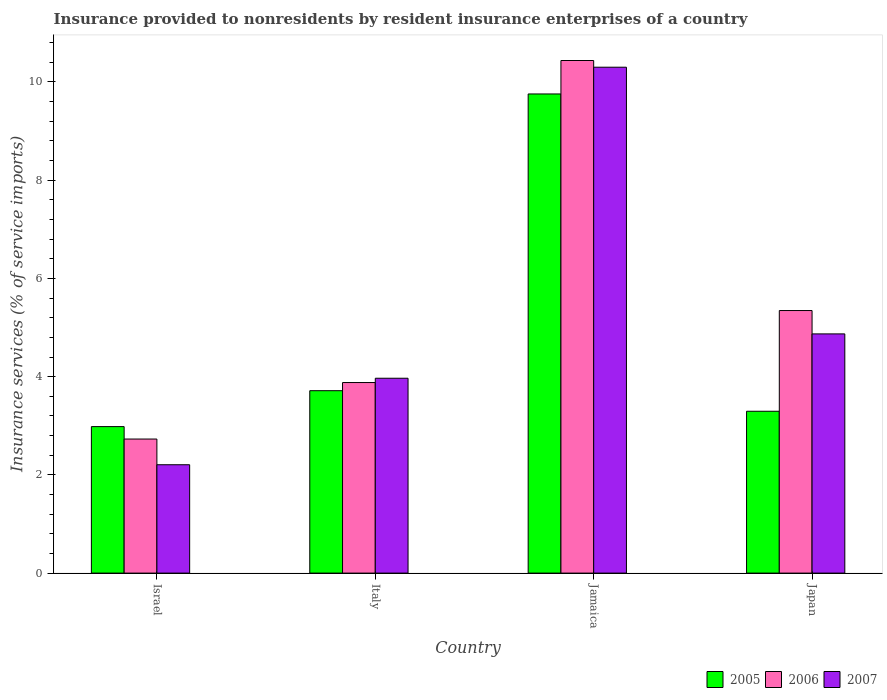How many different coloured bars are there?
Your answer should be very brief. 3. Are the number of bars per tick equal to the number of legend labels?
Your answer should be compact. Yes. Are the number of bars on each tick of the X-axis equal?
Provide a succinct answer. Yes. How many bars are there on the 4th tick from the left?
Offer a terse response. 3. How many bars are there on the 4th tick from the right?
Your answer should be compact. 3. What is the label of the 2nd group of bars from the left?
Your answer should be compact. Italy. In how many cases, is the number of bars for a given country not equal to the number of legend labels?
Your answer should be very brief. 0. What is the insurance provided to nonresidents in 2006 in Italy?
Your answer should be compact. 3.88. Across all countries, what is the maximum insurance provided to nonresidents in 2007?
Ensure brevity in your answer.  10.3. Across all countries, what is the minimum insurance provided to nonresidents in 2005?
Ensure brevity in your answer.  2.98. In which country was the insurance provided to nonresidents in 2006 maximum?
Give a very brief answer. Jamaica. What is the total insurance provided to nonresidents in 2006 in the graph?
Offer a terse response. 22.39. What is the difference between the insurance provided to nonresidents in 2005 in Israel and that in Japan?
Offer a very short reply. -0.31. What is the difference between the insurance provided to nonresidents in 2007 in Italy and the insurance provided to nonresidents in 2006 in Israel?
Provide a short and direct response. 1.24. What is the average insurance provided to nonresidents in 2007 per country?
Provide a succinct answer. 5.34. What is the difference between the insurance provided to nonresidents of/in 2006 and insurance provided to nonresidents of/in 2007 in Japan?
Offer a very short reply. 0.48. What is the ratio of the insurance provided to nonresidents in 2006 in Jamaica to that in Japan?
Your response must be concise. 1.95. What is the difference between the highest and the second highest insurance provided to nonresidents in 2006?
Offer a very short reply. 6.56. What is the difference between the highest and the lowest insurance provided to nonresidents in 2007?
Offer a very short reply. 8.09. Is the sum of the insurance provided to nonresidents in 2007 in Jamaica and Japan greater than the maximum insurance provided to nonresidents in 2005 across all countries?
Your answer should be very brief. Yes. What does the 2nd bar from the left in Israel represents?
Keep it short and to the point. 2006. What does the 3rd bar from the right in Jamaica represents?
Offer a very short reply. 2005. Is it the case that in every country, the sum of the insurance provided to nonresidents in 2007 and insurance provided to nonresidents in 2005 is greater than the insurance provided to nonresidents in 2006?
Offer a very short reply. Yes. Are all the bars in the graph horizontal?
Give a very brief answer. No. How many legend labels are there?
Give a very brief answer. 3. What is the title of the graph?
Your answer should be compact. Insurance provided to nonresidents by resident insurance enterprises of a country. Does "2002" appear as one of the legend labels in the graph?
Keep it short and to the point. No. What is the label or title of the X-axis?
Your answer should be compact. Country. What is the label or title of the Y-axis?
Offer a terse response. Insurance services (% of service imports). What is the Insurance services (% of service imports) of 2005 in Israel?
Offer a terse response. 2.98. What is the Insurance services (% of service imports) in 2006 in Israel?
Give a very brief answer. 2.73. What is the Insurance services (% of service imports) in 2007 in Israel?
Offer a very short reply. 2.21. What is the Insurance services (% of service imports) in 2005 in Italy?
Ensure brevity in your answer.  3.71. What is the Insurance services (% of service imports) in 2006 in Italy?
Give a very brief answer. 3.88. What is the Insurance services (% of service imports) of 2007 in Italy?
Keep it short and to the point. 3.97. What is the Insurance services (% of service imports) in 2005 in Jamaica?
Ensure brevity in your answer.  9.76. What is the Insurance services (% of service imports) in 2006 in Jamaica?
Provide a succinct answer. 10.44. What is the Insurance services (% of service imports) of 2007 in Jamaica?
Give a very brief answer. 10.3. What is the Insurance services (% of service imports) of 2005 in Japan?
Provide a succinct answer. 3.3. What is the Insurance services (% of service imports) of 2006 in Japan?
Provide a short and direct response. 5.35. What is the Insurance services (% of service imports) of 2007 in Japan?
Ensure brevity in your answer.  4.87. Across all countries, what is the maximum Insurance services (% of service imports) of 2005?
Your answer should be compact. 9.76. Across all countries, what is the maximum Insurance services (% of service imports) of 2006?
Provide a short and direct response. 10.44. Across all countries, what is the maximum Insurance services (% of service imports) of 2007?
Your answer should be compact. 10.3. Across all countries, what is the minimum Insurance services (% of service imports) in 2005?
Provide a short and direct response. 2.98. Across all countries, what is the minimum Insurance services (% of service imports) in 2006?
Ensure brevity in your answer.  2.73. Across all countries, what is the minimum Insurance services (% of service imports) in 2007?
Give a very brief answer. 2.21. What is the total Insurance services (% of service imports) of 2005 in the graph?
Keep it short and to the point. 19.75. What is the total Insurance services (% of service imports) of 2006 in the graph?
Offer a terse response. 22.39. What is the total Insurance services (% of service imports) of 2007 in the graph?
Provide a short and direct response. 21.34. What is the difference between the Insurance services (% of service imports) of 2005 in Israel and that in Italy?
Keep it short and to the point. -0.73. What is the difference between the Insurance services (% of service imports) of 2006 in Israel and that in Italy?
Give a very brief answer. -1.15. What is the difference between the Insurance services (% of service imports) of 2007 in Israel and that in Italy?
Your response must be concise. -1.76. What is the difference between the Insurance services (% of service imports) of 2005 in Israel and that in Jamaica?
Offer a very short reply. -6.77. What is the difference between the Insurance services (% of service imports) of 2006 in Israel and that in Jamaica?
Keep it short and to the point. -7.71. What is the difference between the Insurance services (% of service imports) in 2007 in Israel and that in Jamaica?
Offer a very short reply. -8.09. What is the difference between the Insurance services (% of service imports) of 2005 in Israel and that in Japan?
Give a very brief answer. -0.31. What is the difference between the Insurance services (% of service imports) of 2006 in Israel and that in Japan?
Make the answer very short. -2.62. What is the difference between the Insurance services (% of service imports) in 2007 in Israel and that in Japan?
Give a very brief answer. -2.66. What is the difference between the Insurance services (% of service imports) of 2005 in Italy and that in Jamaica?
Keep it short and to the point. -6.04. What is the difference between the Insurance services (% of service imports) in 2006 in Italy and that in Jamaica?
Keep it short and to the point. -6.56. What is the difference between the Insurance services (% of service imports) in 2007 in Italy and that in Jamaica?
Give a very brief answer. -6.33. What is the difference between the Insurance services (% of service imports) of 2005 in Italy and that in Japan?
Make the answer very short. 0.42. What is the difference between the Insurance services (% of service imports) in 2006 in Italy and that in Japan?
Your answer should be very brief. -1.47. What is the difference between the Insurance services (% of service imports) of 2007 in Italy and that in Japan?
Give a very brief answer. -0.9. What is the difference between the Insurance services (% of service imports) of 2005 in Jamaica and that in Japan?
Your response must be concise. 6.46. What is the difference between the Insurance services (% of service imports) in 2006 in Jamaica and that in Japan?
Your answer should be very brief. 5.09. What is the difference between the Insurance services (% of service imports) of 2007 in Jamaica and that in Japan?
Your answer should be compact. 5.43. What is the difference between the Insurance services (% of service imports) in 2005 in Israel and the Insurance services (% of service imports) in 2006 in Italy?
Make the answer very short. -0.9. What is the difference between the Insurance services (% of service imports) in 2005 in Israel and the Insurance services (% of service imports) in 2007 in Italy?
Offer a terse response. -0.98. What is the difference between the Insurance services (% of service imports) in 2006 in Israel and the Insurance services (% of service imports) in 2007 in Italy?
Make the answer very short. -1.24. What is the difference between the Insurance services (% of service imports) of 2005 in Israel and the Insurance services (% of service imports) of 2006 in Jamaica?
Make the answer very short. -7.45. What is the difference between the Insurance services (% of service imports) in 2005 in Israel and the Insurance services (% of service imports) in 2007 in Jamaica?
Ensure brevity in your answer.  -7.32. What is the difference between the Insurance services (% of service imports) of 2006 in Israel and the Insurance services (% of service imports) of 2007 in Jamaica?
Your answer should be compact. -7.57. What is the difference between the Insurance services (% of service imports) of 2005 in Israel and the Insurance services (% of service imports) of 2006 in Japan?
Provide a short and direct response. -2.36. What is the difference between the Insurance services (% of service imports) of 2005 in Israel and the Insurance services (% of service imports) of 2007 in Japan?
Provide a short and direct response. -1.89. What is the difference between the Insurance services (% of service imports) in 2006 in Israel and the Insurance services (% of service imports) in 2007 in Japan?
Offer a very short reply. -2.14. What is the difference between the Insurance services (% of service imports) in 2005 in Italy and the Insurance services (% of service imports) in 2006 in Jamaica?
Provide a succinct answer. -6.72. What is the difference between the Insurance services (% of service imports) in 2005 in Italy and the Insurance services (% of service imports) in 2007 in Jamaica?
Offer a very short reply. -6.59. What is the difference between the Insurance services (% of service imports) of 2006 in Italy and the Insurance services (% of service imports) of 2007 in Jamaica?
Provide a succinct answer. -6.42. What is the difference between the Insurance services (% of service imports) in 2005 in Italy and the Insurance services (% of service imports) in 2006 in Japan?
Your answer should be compact. -1.63. What is the difference between the Insurance services (% of service imports) in 2005 in Italy and the Insurance services (% of service imports) in 2007 in Japan?
Offer a very short reply. -1.16. What is the difference between the Insurance services (% of service imports) in 2006 in Italy and the Insurance services (% of service imports) in 2007 in Japan?
Make the answer very short. -0.99. What is the difference between the Insurance services (% of service imports) of 2005 in Jamaica and the Insurance services (% of service imports) of 2006 in Japan?
Make the answer very short. 4.41. What is the difference between the Insurance services (% of service imports) in 2005 in Jamaica and the Insurance services (% of service imports) in 2007 in Japan?
Make the answer very short. 4.89. What is the difference between the Insurance services (% of service imports) of 2006 in Jamaica and the Insurance services (% of service imports) of 2007 in Japan?
Keep it short and to the point. 5.57. What is the average Insurance services (% of service imports) of 2005 per country?
Your answer should be very brief. 4.94. What is the average Insurance services (% of service imports) in 2006 per country?
Your answer should be compact. 5.6. What is the average Insurance services (% of service imports) in 2007 per country?
Make the answer very short. 5.34. What is the difference between the Insurance services (% of service imports) of 2005 and Insurance services (% of service imports) of 2006 in Israel?
Give a very brief answer. 0.25. What is the difference between the Insurance services (% of service imports) of 2005 and Insurance services (% of service imports) of 2007 in Israel?
Ensure brevity in your answer.  0.78. What is the difference between the Insurance services (% of service imports) of 2006 and Insurance services (% of service imports) of 2007 in Israel?
Give a very brief answer. 0.52. What is the difference between the Insurance services (% of service imports) of 2005 and Insurance services (% of service imports) of 2006 in Italy?
Offer a very short reply. -0.17. What is the difference between the Insurance services (% of service imports) in 2005 and Insurance services (% of service imports) in 2007 in Italy?
Keep it short and to the point. -0.25. What is the difference between the Insurance services (% of service imports) of 2006 and Insurance services (% of service imports) of 2007 in Italy?
Your answer should be compact. -0.09. What is the difference between the Insurance services (% of service imports) of 2005 and Insurance services (% of service imports) of 2006 in Jamaica?
Keep it short and to the point. -0.68. What is the difference between the Insurance services (% of service imports) of 2005 and Insurance services (% of service imports) of 2007 in Jamaica?
Offer a very short reply. -0.54. What is the difference between the Insurance services (% of service imports) in 2006 and Insurance services (% of service imports) in 2007 in Jamaica?
Your answer should be very brief. 0.14. What is the difference between the Insurance services (% of service imports) of 2005 and Insurance services (% of service imports) of 2006 in Japan?
Provide a succinct answer. -2.05. What is the difference between the Insurance services (% of service imports) of 2005 and Insurance services (% of service imports) of 2007 in Japan?
Your answer should be very brief. -1.58. What is the difference between the Insurance services (% of service imports) in 2006 and Insurance services (% of service imports) in 2007 in Japan?
Provide a short and direct response. 0.48. What is the ratio of the Insurance services (% of service imports) of 2005 in Israel to that in Italy?
Provide a short and direct response. 0.8. What is the ratio of the Insurance services (% of service imports) of 2006 in Israel to that in Italy?
Your answer should be very brief. 0.7. What is the ratio of the Insurance services (% of service imports) of 2007 in Israel to that in Italy?
Keep it short and to the point. 0.56. What is the ratio of the Insurance services (% of service imports) of 2005 in Israel to that in Jamaica?
Your response must be concise. 0.31. What is the ratio of the Insurance services (% of service imports) in 2006 in Israel to that in Jamaica?
Your answer should be compact. 0.26. What is the ratio of the Insurance services (% of service imports) of 2007 in Israel to that in Jamaica?
Provide a succinct answer. 0.21. What is the ratio of the Insurance services (% of service imports) in 2005 in Israel to that in Japan?
Provide a succinct answer. 0.91. What is the ratio of the Insurance services (% of service imports) in 2006 in Israel to that in Japan?
Offer a terse response. 0.51. What is the ratio of the Insurance services (% of service imports) in 2007 in Israel to that in Japan?
Ensure brevity in your answer.  0.45. What is the ratio of the Insurance services (% of service imports) in 2005 in Italy to that in Jamaica?
Offer a terse response. 0.38. What is the ratio of the Insurance services (% of service imports) of 2006 in Italy to that in Jamaica?
Your answer should be compact. 0.37. What is the ratio of the Insurance services (% of service imports) of 2007 in Italy to that in Jamaica?
Ensure brevity in your answer.  0.39. What is the ratio of the Insurance services (% of service imports) in 2005 in Italy to that in Japan?
Give a very brief answer. 1.13. What is the ratio of the Insurance services (% of service imports) in 2006 in Italy to that in Japan?
Provide a short and direct response. 0.73. What is the ratio of the Insurance services (% of service imports) in 2007 in Italy to that in Japan?
Provide a short and direct response. 0.81. What is the ratio of the Insurance services (% of service imports) of 2005 in Jamaica to that in Japan?
Your answer should be very brief. 2.96. What is the ratio of the Insurance services (% of service imports) of 2006 in Jamaica to that in Japan?
Give a very brief answer. 1.95. What is the ratio of the Insurance services (% of service imports) in 2007 in Jamaica to that in Japan?
Give a very brief answer. 2.11. What is the difference between the highest and the second highest Insurance services (% of service imports) of 2005?
Your answer should be compact. 6.04. What is the difference between the highest and the second highest Insurance services (% of service imports) in 2006?
Provide a succinct answer. 5.09. What is the difference between the highest and the second highest Insurance services (% of service imports) of 2007?
Make the answer very short. 5.43. What is the difference between the highest and the lowest Insurance services (% of service imports) in 2005?
Your answer should be compact. 6.77. What is the difference between the highest and the lowest Insurance services (% of service imports) in 2006?
Ensure brevity in your answer.  7.71. What is the difference between the highest and the lowest Insurance services (% of service imports) of 2007?
Offer a very short reply. 8.09. 